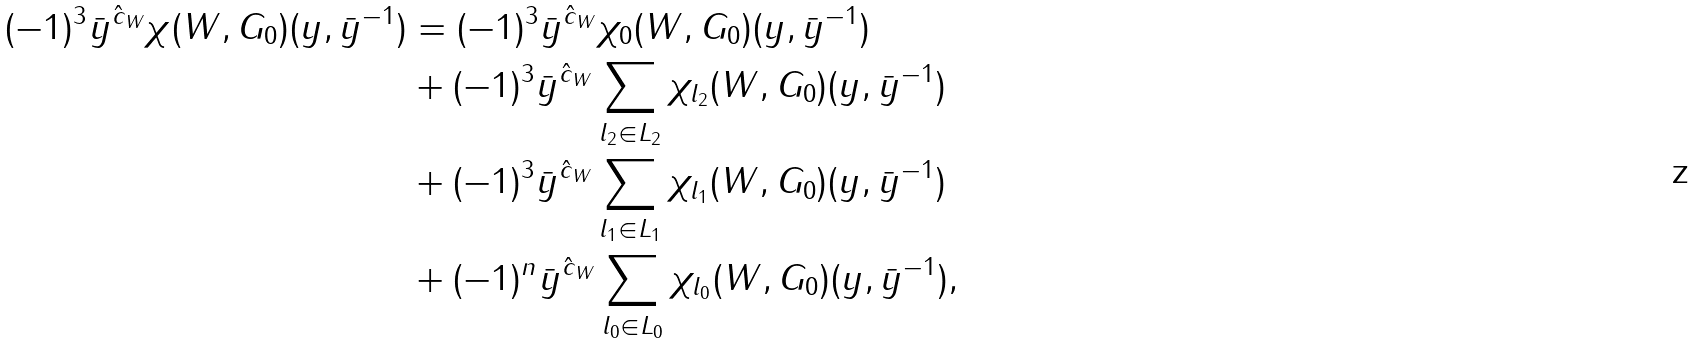<formula> <loc_0><loc_0><loc_500><loc_500>( - 1 ) ^ { 3 } \bar { y } ^ { \hat { c } _ { W } } \chi ( W , G _ { 0 } ) ( y , \bar { y } ^ { - 1 } ) & = ( - 1 ) ^ { 3 } \bar { y } ^ { \hat { c } _ { W } } \chi _ { 0 } ( W , G _ { 0 } ) ( y , \bar { y } ^ { - 1 } ) \\ & + ( - 1 ) ^ { 3 } \bar { y } ^ { \hat { c } _ { W } } \sum _ { l _ { 2 } \in L _ { 2 } } \chi _ { l _ { 2 } } ( W , G _ { 0 } ) ( y , \bar { y } ^ { - 1 } ) \\ & + ( - 1 ) ^ { 3 } \bar { y } ^ { \hat { c } _ { W } } \sum _ { l _ { 1 } \in L _ { 1 } } \chi _ { l _ { 1 } } ( W , G _ { 0 } ) ( y , \bar { y } ^ { - 1 } ) \\ & + ( - 1 ) ^ { n } \bar { y } ^ { \hat { c } _ { W } } \sum _ { l _ { 0 } \in L _ { 0 } } \chi _ { l _ { 0 } } ( W , G _ { 0 } ) ( y , \bar { y } ^ { - 1 } ) ,</formula> 